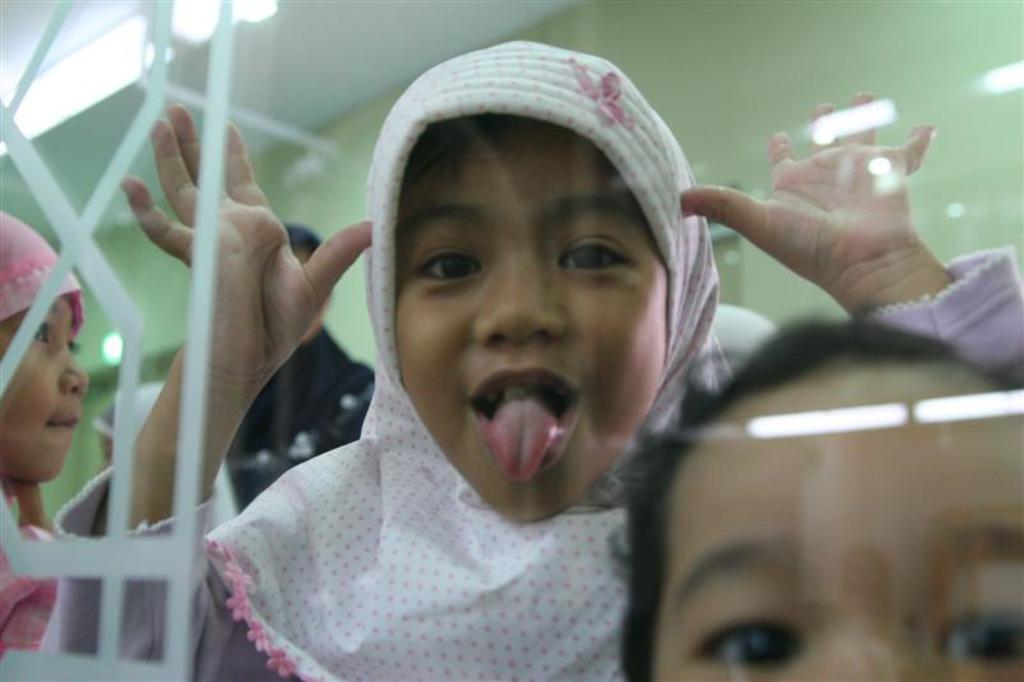Who is the main subject in the image? There is a girl in the image. What is the girl doing in the image? The girl is showing her tongue and raising her two hands. What is the girl wearing on her head? The girl is wearing a white color hijab. What type of wine is the girl holding in the image? There is no wine present in the image; the girl is not holding any wine. What form does the tree in the image take? There is no tree present in the image. 